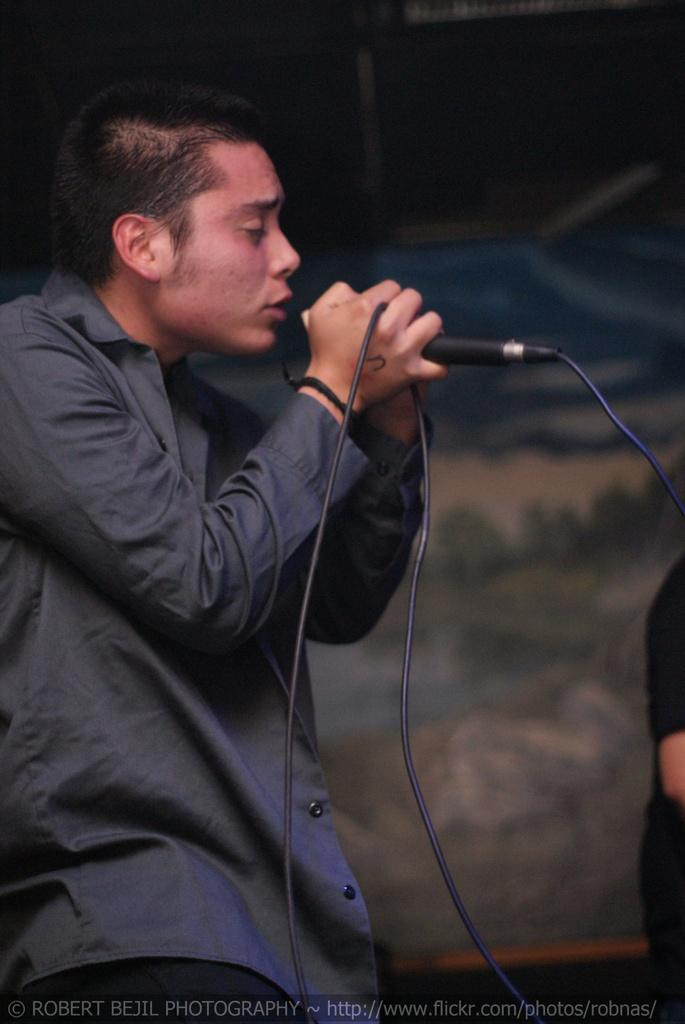What is the man in the image doing? The man is singing in the image. How is the man holding the microphone? The man is holding the microphone in his hand. What is the man wearing in the image? The man is wearing a black shirt. Can you describe the other human in the image? There is another human in the image, but no specific details are provided. What object is visible in the image that is made of cloth? There is a cloth visible in the image, but no specific details are provided about its purpose or location. How many zebras are visible in the image? There are no zebras present in the image. What type of skin condition does the man in the image have? There is no information provided about the man's skin condition in the image. 